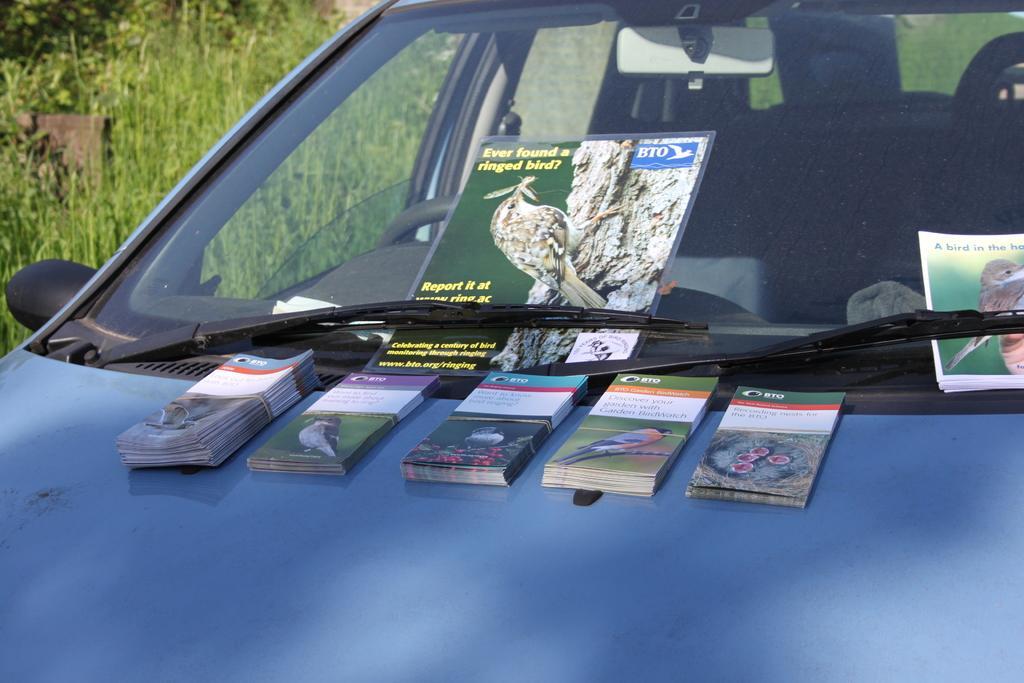Could you give a brief overview of what you see in this image? In this picture in the center there are papers on the car. On the left side there's grass on the ground. 